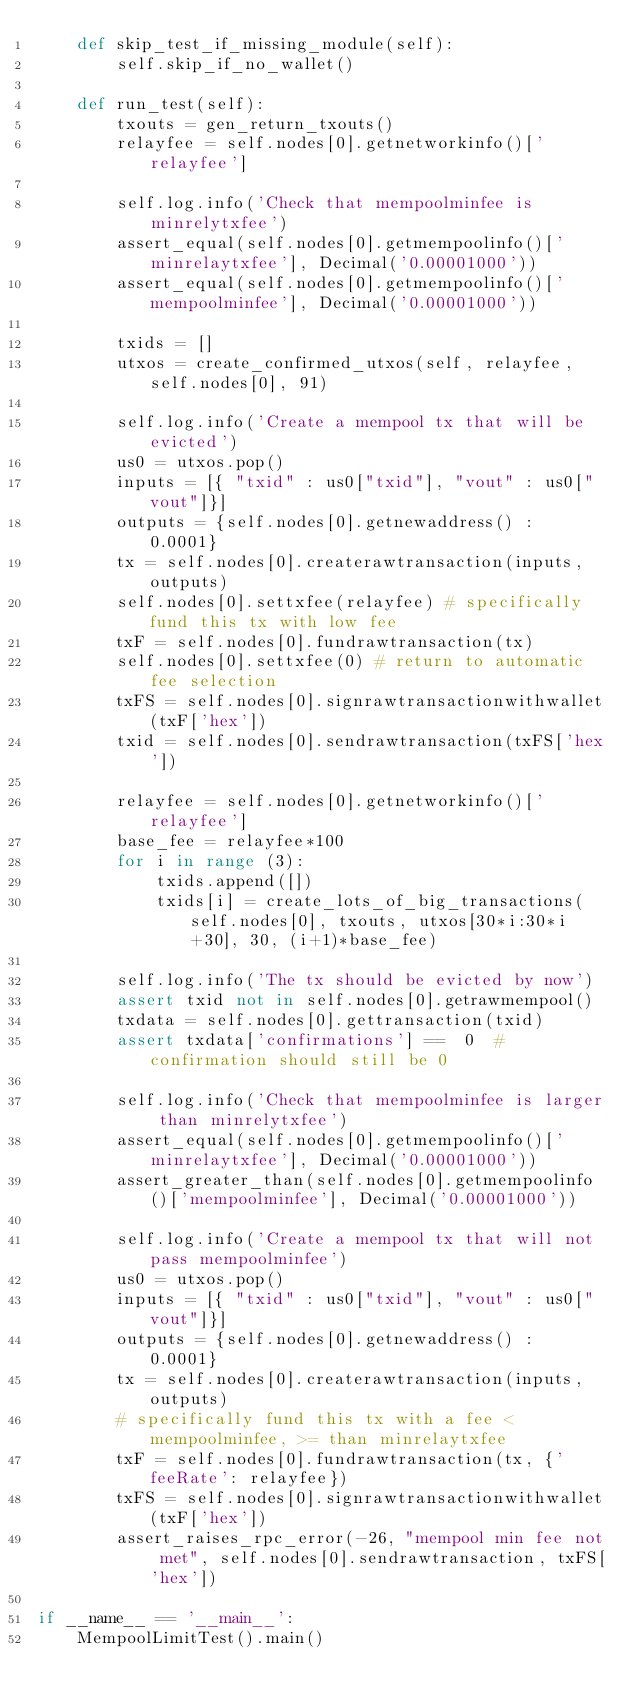<code> <loc_0><loc_0><loc_500><loc_500><_Python_>    def skip_test_if_missing_module(self):
        self.skip_if_no_wallet()

    def run_test(self):
        txouts = gen_return_txouts()
        relayfee = self.nodes[0].getnetworkinfo()['relayfee']

        self.log.info('Check that mempoolminfee is minrelytxfee')
        assert_equal(self.nodes[0].getmempoolinfo()['minrelaytxfee'], Decimal('0.00001000'))
        assert_equal(self.nodes[0].getmempoolinfo()['mempoolminfee'], Decimal('0.00001000'))

        txids = []
        utxos = create_confirmed_utxos(self, relayfee, self.nodes[0], 91)

        self.log.info('Create a mempool tx that will be evicted')
        us0 = utxos.pop()
        inputs = [{ "txid" : us0["txid"], "vout" : us0["vout"]}]
        outputs = {self.nodes[0].getnewaddress() : 0.0001}
        tx = self.nodes[0].createrawtransaction(inputs, outputs)
        self.nodes[0].settxfee(relayfee) # specifically fund this tx with low fee
        txF = self.nodes[0].fundrawtransaction(tx)
        self.nodes[0].settxfee(0) # return to automatic fee selection
        txFS = self.nodes[0].signrawtransactionwithwallet(txF['hex'])
        txid = self.nodes[0].sendrawtransaction(txFS['hex'])

        relayfee = self.nodes[0].getnetworkinfo()['relayfee']
        base_fee = relayfee*100
        for i in range (3):
            txids.append([])
            txids[i] = create_lots_of_big_transactions(self.nodes[0], txouts, utxos[30*i:30*i+30], 30, (i+1)*base_fee)

        self.log.info('The tx should be evicted by now')
        assert txid not in self.nodes[0].getrawmempool()
        txdata = self.nodes[0].gettransaction(txid)
        assert txdata['confirmations'] ==  0  #confirmation should still be 0

        self.log.info('Check that mempoolminfee is larger than minrelytxfee')
        assert_equal(self.nodes[0].getmempoolinfo()['minrelaytxfee'], Decimal('0.00001000'))
        assert_greater_than(self.nodes[0].getmempoolinfo()['mempoolminfee'], Decimal('0.00001000'))

        self.log.info('Create a mempool tx that will not pass mempoolminfee')
        us0 = utxos.pop()
        inputs = [{ "txid" : us0["txid"], "vout" : us0["vout"]}]
        outputs = {self.nodes[0].getnewaddress() : 0.0001}
        tx = self.nodes[0].createrawtransaction(inputs, outputs)
        # specifically fund this tx with a fee < mempoolminfee, >= than minrelaytxfee
        txF = self.nodes[0].fundrawtransaction(tx, {'feeRate': relayfee})
        txFS = self.nodes[0].signrawtransactionwithwallet(txF['hex'])
        assert_raises_rpc_error(-26, "mempool min fee not met", self.nodes[0].sendrawtransaction, txFS['hex'])

if __name__ == '__main__':
    MempoolLimitTest().main()
</code> 